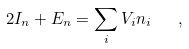Convert formula to latex. <formula><loc_0><loc_0><loc_500><loc_500>2 I _ { n } + E _ { n } = \sum _ { i } V _ { i } n _ { i } \quad ,</formula> 